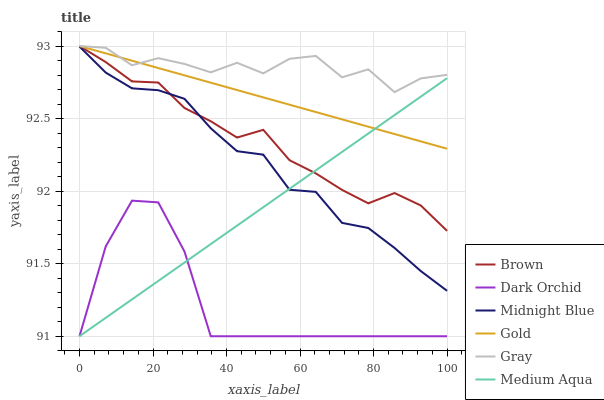Does Dark Orchid have the minimum area under the curve?
Answer yes or no. Yes. Does Gray have the maximum area under the curve?
Answer yes or no. Yes. Does Midnight Blue have the minimum area under the curve?
Answer yes or no. No. Does Midnight Blue have the maximum area under the curve?
Answer yes or no. No. Is Gold the smoothest?
Answer yes or no. Yes. Is Gray the roughest?
Answer yes or no. Yes. Is Midnight Blue the smoothest?
Answer yes or no. No. Is Midnight Blue the roughest?
Answer yes or no. No. Does Dark Orchid have the lowest value?
Answer yes or no. Yes. Does Midnight Blue have the lowest value?
Answer yes or no. No. Does Gray have the highest value?
Answer yes or no. Yes. Does Midnight Blue have the highest value?
Answer yes or no. No. Is Dark Orchid less than Gold?
Answer yes or no. Yes. Is Gold greater than Midnight Blue?
Answer yes or no. Yes. Does Medium Aqua intersect Gold?
Answer yes or no. Yes. Is Medium Aqua less than Gold?
Answer yes or no. No. Is Medium Aqua greater than Gold?
Answer yes or no. No. Does Dark Orchid intersect Gold?
Answer yes or no. No. 